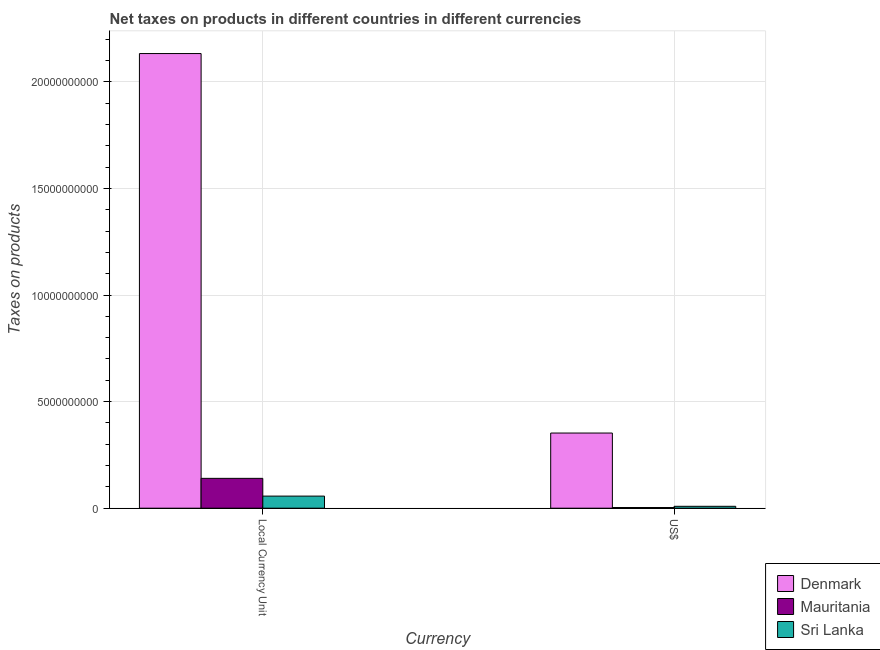How many different coloured bars are there?
Your answer should be compact. 3. How many groups of bars are there?
Keep it short and to the point. 2. How many bars are there on the 1st tick from the right?
Give a very brief answer. 3. What is the label of the 1st group of bars from the left?
Offer a terse response. Local Currency Unit. What is the net taxes in us$ in Sri Lanka?
Ensure brevity in your answer.  8.86e+07. Across all countries, what is the maximum net taxes in us$?
Make the answer very short. 3.53e+09. Across all countries, what is the minimum net taxes in us$?
Your answer should be very brief. 3.14e+07. In which country was the net taxes in us$ maximum?
Offer a terse response. Denmark. In which country was the net taxes in constant 2005 us$ minimum?
Make the answer very short. Sri Lanka. What is the total net taxes in constant 2005 us$ in the graph?
Your answer should be very brief. 2.33e+1. What is the difference between the net taxes in constant 2005 us$ in Denmark and that in Sri Lanka?
Keep it short and to the point. 2.08e+1. What is the difference between the net taxes in constant 2005 us$ in Sri Lanka and the net taxes in us$ in Mauritania?
Keep it short and to the point. 5.36e+08. What is the average net taxes in constant 2005 us$ per country?
Offer a very short reply. 7.77e+09. What is the difference between the net taxes in constant 2005 us$ and net taxes in us$ in Mauritania?
Your response must be concise. 1.37e+09. In how many countries, is the net taxes in us$ greater than 16000000000 units?
Offer a very short reply. 0. What is the ratio of the net taxes in us$ in Mauritania to that in Sri Lanka?
Offer a very short reply. 0.35. In how many countries, is the net taxes in us$ greater than the average net taxes in us$ taken over all countries?
Give a very brief answer. 1. What does the 2nd bar from the left in Local Currency Unit represents?
Your answer should be very brief. Mauritania. What does the 1st bar from the right in US$ represents?
Offer a very short reply. Sri Lanka. What is the difference between two consecutive major ticks on the Y-axis?
Offer a very short reply. 5.00e+09. Does the graph contain any zero values?
Your response must be concise. No. Where does the legend appear in the graph?
Give a very brief answer. Bottom right. How are the legend labels stacked?
Keep it short and to the point. Vertical. What is the title of the graph?
Your answer should be compact. Net taxes on products in different countries in different currencies. What is the label or title of the X-axis?
Ensure brevity in your answer.  Currency. What is the label or title of the Y-axis?
Keep it short and to the point. Taxes on products. What is the Taxes on products in Denmark in Local Currency Unit?
Make the answer very short. 2.13e+1. What is the Taxes on products of Mauritania in Local Currency Unit?
Offer a very short reply. 1.40e+09. What is the Taxes on products of Sri Lanka in Local Currency Unit?
Your response must be concise. 5.67e+08. What is the Taxes on products of Denmark in US$?
Offer a terse response. 3.53e+09. What is the Taxes on products of Mauritania in US$?
Offer a terse response. 3.14e+07. What is the Taxes on products in Sri Lanka in US$?
Offer a very short reply. 8.86e+07. Across all Currency, what is the maximum Taxes on products in Denmark?
Offer a terse response. 2.13e+1. Across all Currency, what is the maximum Taxes on products in Mauritania?
Keep it short and to the point. 1.40e+09. Across all Currency, what is the maximum Taxes on products of Sri Lanka?
Give a very brief answer. 5.67e+08. Across all Currency, what is the minimum Taxes on products in Denmark?
Ensure brevity in your answer.  3.53e+09. Across all Currency, what is the minimum Taxes on products of Mauritania?
Ensure brevity in your answer.  3.14e+07. Across all Currency, what is the minimum Taxes on products in Sri Lanka?
Give a very brief answer. 8.86e+07. What is the total Taxes on products of Denmark in the graph?
Keep it short and to the point. 2.49e+1. What is the total Taxes on products in Mauritania in the graph?
Keep it short and to the point. 1.43e+09. What is the total Taxes on products of Sri Lanka in the graph?
Your answer should be very brief. 6.56e+08. What is the difference between the Taxes on products in Denmark in Local Currency Unit and that in US$?
Provide a short and direct response. 1.78e+1. What is the difference between the Taxes on products of Mauritania in Local Currency Unit and that in US$?
Provide a succinct answer. 1.37e+09. What is the difference between the Taxes on products of Sri Lanka in Local Currency Unit and that in US$?
Make the answer very short. 4.78e+08. What is the difference between the Taxes on products of Denmark in Local Currency Unit and the Taxes on products of Mauritania in US$?
Provide a succinct answer. 2.13e+1. What is the difference between the Taxes on products in Denmark in Local Currency Unit and the Taxes on products in Sri Lanka in US$?
Give a very brief answer. 2.12e+1. What is the difference between the Taxes on products in Mauritania in Local Currency Unit and the Taxes on products in Sri Lanka in US$?
Your answer should be very brief. 1.31e+09. What is the average Taxes on products in Denmark per Currency?
Provide a short and direct response. 1.24e+1. What is the average Taxes on products of Mauritania per Currency?
Provide a short and direct response. 7.16e+08. What is the average Taxes on products in Sri Lanka per Currency?
Provide a short and direct response. 3.28e+08. What is the difference between the Taxes on products of Denmark and Taxes on products of Mauritania in Local Currency Unit?
Make the answer very short. 1.99e+1. What is the difference between the Taxes on products of Denmark and Taxes on products of Sri Lanka in Local Currency Unit?
Your answer should be very brief. 2.08e+1. What is the difference between the Taxes on products in Mauritania and Taxes on products in Sri Lanka in Local Currency Unit?
Your answer should be very brief. 8.33e+08. What is the difference between the Taxes on products of Denmark and Taxes on products of Mauritania in US$?
Give a very brief answer. 3.49e+09. What is the difference between the Taxes on products of Denmark and Taxes on products of Sri Lanka in US$?
Keep it short and to the point. 3.44e+09. What is the difference between the Taxes on products of Mauritania and Taxes on products of Sri Lanka in US$?
Your response must be concise. -5.72e+07. What is the ratio of the Taxes on products of Denmark in Local Currency Unit to that in US$?
Provide a short and direct response. 6.05. What is the ratio of the Taxes on products in Mauritania in Local Currency Unit to that in US$?
Give a very brief answer. 44.58. What is the difference between the highest and the second highest Taxes on products in Denmark?
Give a very brief answer. 1.78e+1. What is the difference between the highest and the second highest Taxes on products of Mauritania?
Provide a succinct answer. 1.37e+09. What is the difference between the highest and the second highest Taxes on products in Sri Lanka?
Provide a short and direct response. 4.78e+08. What is the difference between the highest and the lowest Taxes on products of Denmark?
Provide a succinct answer. 1.78e+1. What is the difference between the highest and the lowest Taxes on products of Mauritania?
Your answer should be very brief. 1.37e+09. What is the difference between the highest and the lowest Taxes on products of Sri Lanka?
Provide a short and direct response. 4.78e+08. 